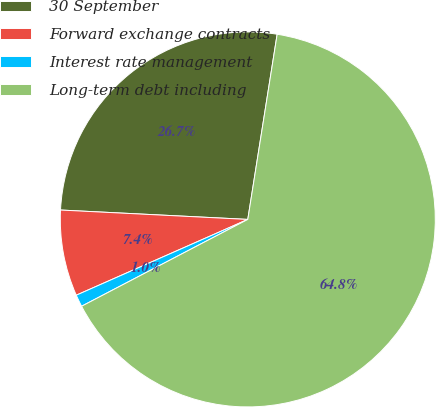Convert chart to OTSL. <chart><loc_0><loc_0><loc_500><loc_500><pie_chart><fcel>30 September<fcel>Forward exchange contracts<fcel>Interest rate management<fcel>Long-term debt including<nl><fcel>26.71%<fcel>7.42%<fcel>1.04%<fcel>64.84%<nl></chart> 